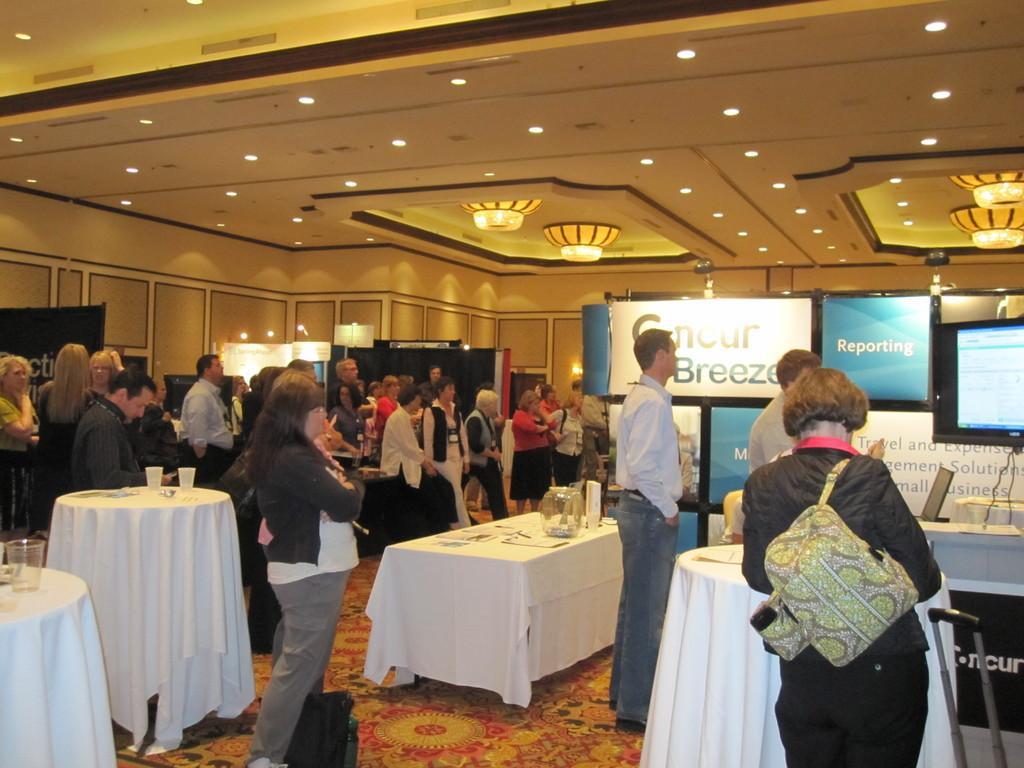Can you describe this image briefly? There are group of people standing and there is a table and some televisions in front of them. 